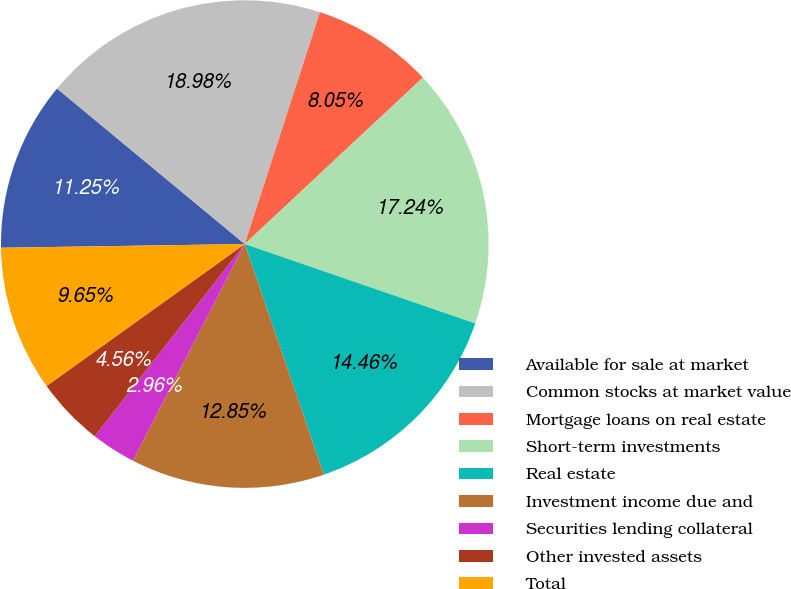Convert chart. <chart><loc_0><loc_0><loc_500><loc_500><pie_chart><fcel>Available for sale at market<fcel>Common stocks at market value<fcel>Mortgage loans on real estate<fcel>Short-term investments<fcel>Real estate<fcel>Investment income due and<fcel>Securities lending collateral<fcel>Other invested assets<fcel>Total<nl><fcel>11.25%<fcel>18.98%<fcel>8.05%<fcel>17.24%<fcel>14.46%<fcel>12.85%<fcel>2.96%<fcel>4.56%<fcel>9.65%<nl></chart> 